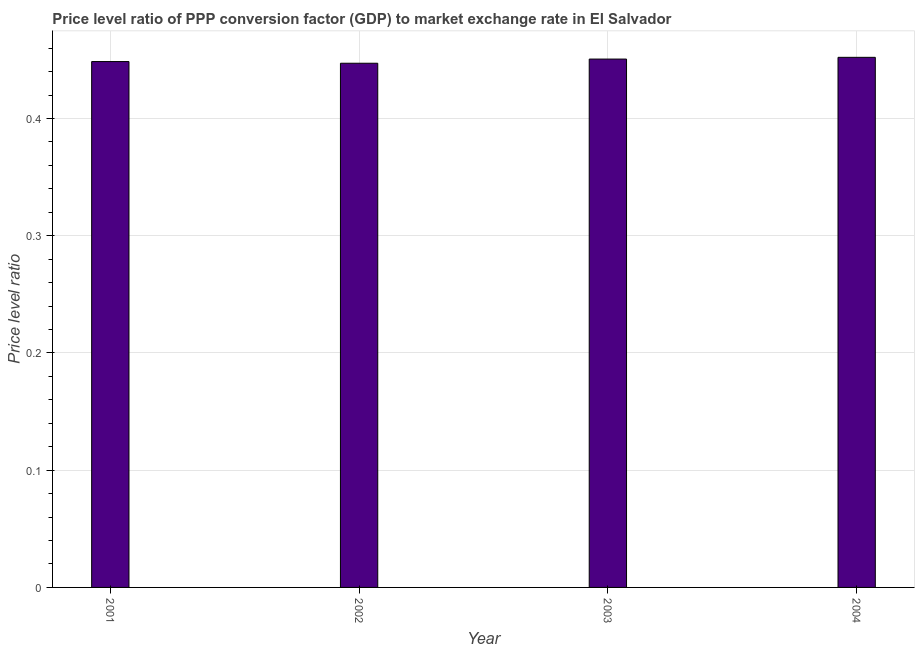Does the graph contain any zero values?
Make the answer very short. No. What is the title of the graph?
Keep it short and to the point. Price level ratio of PPP conversion factor (GDP) to market exchange rate in El Salvador. What is the label or title of the Y-axis?
Offer a terse response. Price level ratio. What is the price level ratio in 2004?
Offer a very short reply. 0.45. Across all years, what is the maximum price level ratio?
Keep it short and to the point. 0.45. Across all years, what is the minimum price level ratio?
Your answer should be compact. 0.45. In which year was the price level ratio maximum?
Offer a terse response. 2004. What is the sum of the price level ratio?
Your response must be concise. 1.8. What is the difference between the price level ratio in 2001 and 2004?
Keep it short and to the point. -0. What is the average price level ratio per year?
Your answer should be very brief. 0.45. What is the median price level ratio?
Your answer should be compact. 0.45. Do a majority of the years between 2002 and 2003 (inclusive) have price level ratio greater than 0.04 ?
Keep it short and to the point. Yes. Is the price level ratio in 2001 less than that in 2002?
Provide a succinct answer. No. Is the difference between the price level ratio in 2001 and 2002 greater than the difference between any two years?
Offer a very short reply. No. What is the difference between the highest and the second highest price level ratio?
Ensure brevity in your answer.  0. Is the sum of the price level ratio in 2002 and 2003 greater than the maximum price level ratio across all years?
Your answer should be very brief. Yes. How many bars are there?
Give a very brief answer. 4. What is the Price level ratio of 2001?
Offer a terse response. 0.45. What is the Price level ratio in 2002?
Offer a terse response. 0.45. What is the Price level ratio in 2003?
Offer a terse response. 0.45. What is the Price level ratio in 2004?
Provide a short and direct response. 0.45. What is the difference between the Price level ratio in 2001 and 2002?
Provide a succinct answer. 0. What is the difference between the Price level ratio in 2001 and 2003?
Make the answer very short. -0. What is the difference between the Price level ratio in 2001 and 2004?
Offer a terse response. -0. What is the difference between the Price level ratio in 2002 and 2003?
Your answer should be very brief. -0. What is the difference between the Price level ratio in 2002 and 2004?
Provide a succinct answer. -0.01. What is the difference between the Price level ratio in 2003 and 2004?
Give a very brief answer. -0. What is the ratio of the Price level ratio in 2001 to that in 2002?
Provide a short and direct response. 1. What is the ratio of the Price level ratio in 2001 to that in 2003?
Your answer should be very brief. 0.99. What is the ratio of the Price level ratio in 2001 to that in 2004?
Keep it short and to the point. 0.99. What is the ratio of the Price level ratio in 2002 to that in 2003?
Your answer should be compact. 0.99. What is the ratio of the Price level ratio in 2002 to that in 2004?
Your answer should be compact. 0.99. What is the ratio of the Price level ratio in 2003 to that in 2004?
Offer a very short reply. 1. 